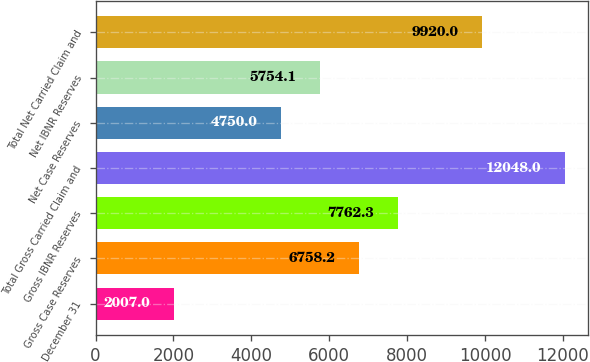<chart> <loc_0><loc_0><loc_500><loc_500><bar_chart><fcel>December 31<fcel>Gross Case Reserves<fcel>Gross IBNR Reserves<fcel>Total Gross Carried Claim and<fcel>Net Case Reserves<fcel>Net IBNR Reserves<fcel>Total Net Carried Claim and<nl><fcel>2007<fcel>6758.2<fcel>7762.3<fcel>12048<fcel>4750<fcel>5754.1<fcel>9920<nl></chart> 